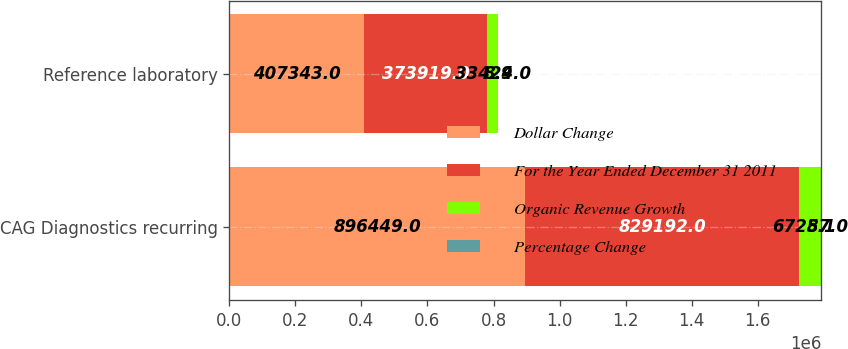Convert chart. <chart><loc_0><loc_0><loc_500><loc_500><stacked_bar_chart><ecel><fcel>CAG Diagnostics recurring<fcel>Reference laboratory<nl><fcel>Dollar Change<fcel>896449<fcel>407343<nl><fcel>For the Year Ended December 31 2011<fcel>829192<fcel>373919<nl><fcel>Organic Revenue Growth<fcel>67257<fcel>33424<nl><fcel>Percentage Change<fcel>8.1<fcel>8.9<nl></chart> 